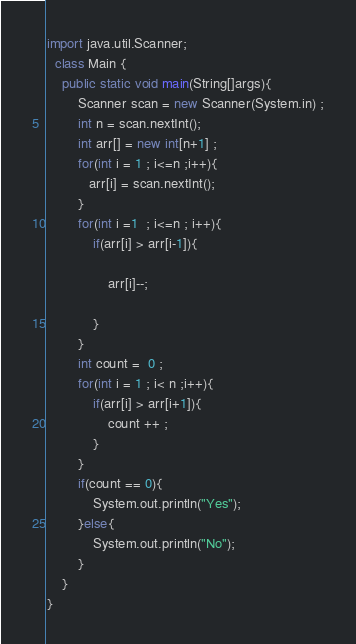Convert code to text. <code><loc_0><loc_0><loc_500><loc_500><_Java_>
import java.util.Scanner;
  class Main {
    public static void main(String[]args){
        Scanner scan = new Scanner(System.in) ;
        int n = scan.nextInt();
        int arr[] = new int[n+1] ;
        for(int i = 1 ; i<=n ;i++){
           arr[i] = scan.nextInt();
        }
        for(int i =1  ; i<=n ; i++){
            if(arr[i] > arr[i-1]){
               
                arr[i]--;
               
            } 
        }
        int count =  0 ; 
        for(int i = 1 ; i< n ;i++){
            if(arr[i] > arr[i+1]){
                count ++ ;
            }
        }
        if(count == 0){
            System.out.println("Yes");
        }else{
            System.out.println("No");
        }
    }
}
</code> 